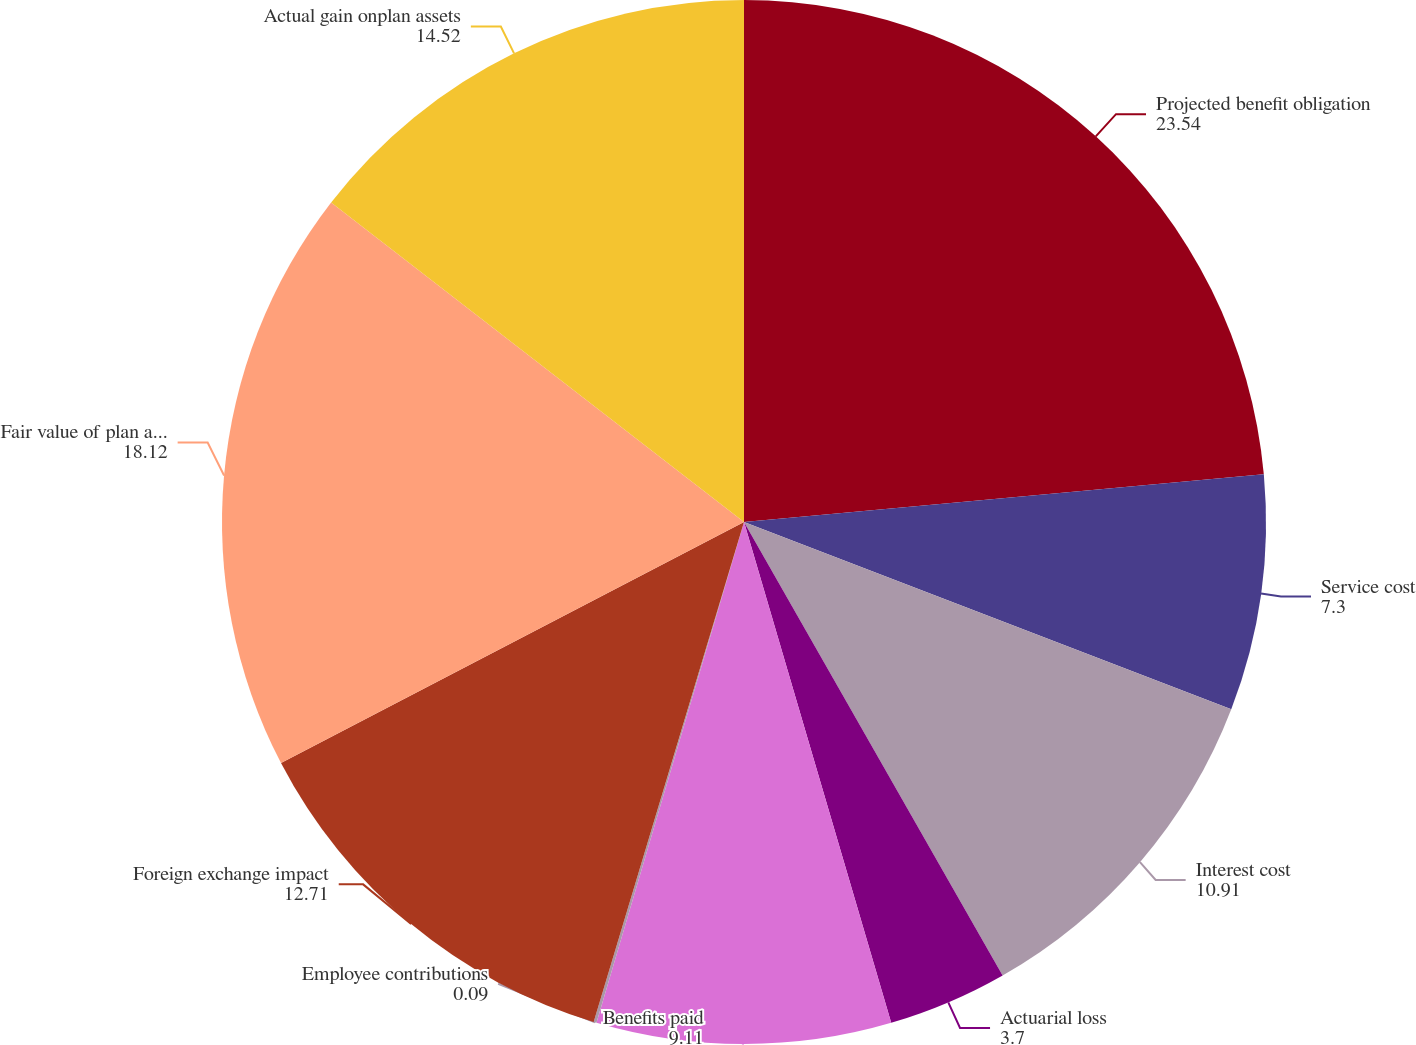<chart> <loc_0><loc_0><loc_500><loc_500><pie_chart><fcel>Projected benefit obligation<fcel>Service cost<fcel>Interest cost<fcel>Actuarial loss<fcel>Benefits paid<fcel>Employee contributions<fcel>Foreign exchange impact<fcel>Fair value of plan assets at<fcel>Actual gain onplan assets<nl><fcel>23.54%<fcel>7.3%<fcel>10.91%<fcel>3.7%<fcel>9.11%<fcel>0.09%<fcel>12.71%<fcel>18.12%<fcel>14.52%<nl></chart> 